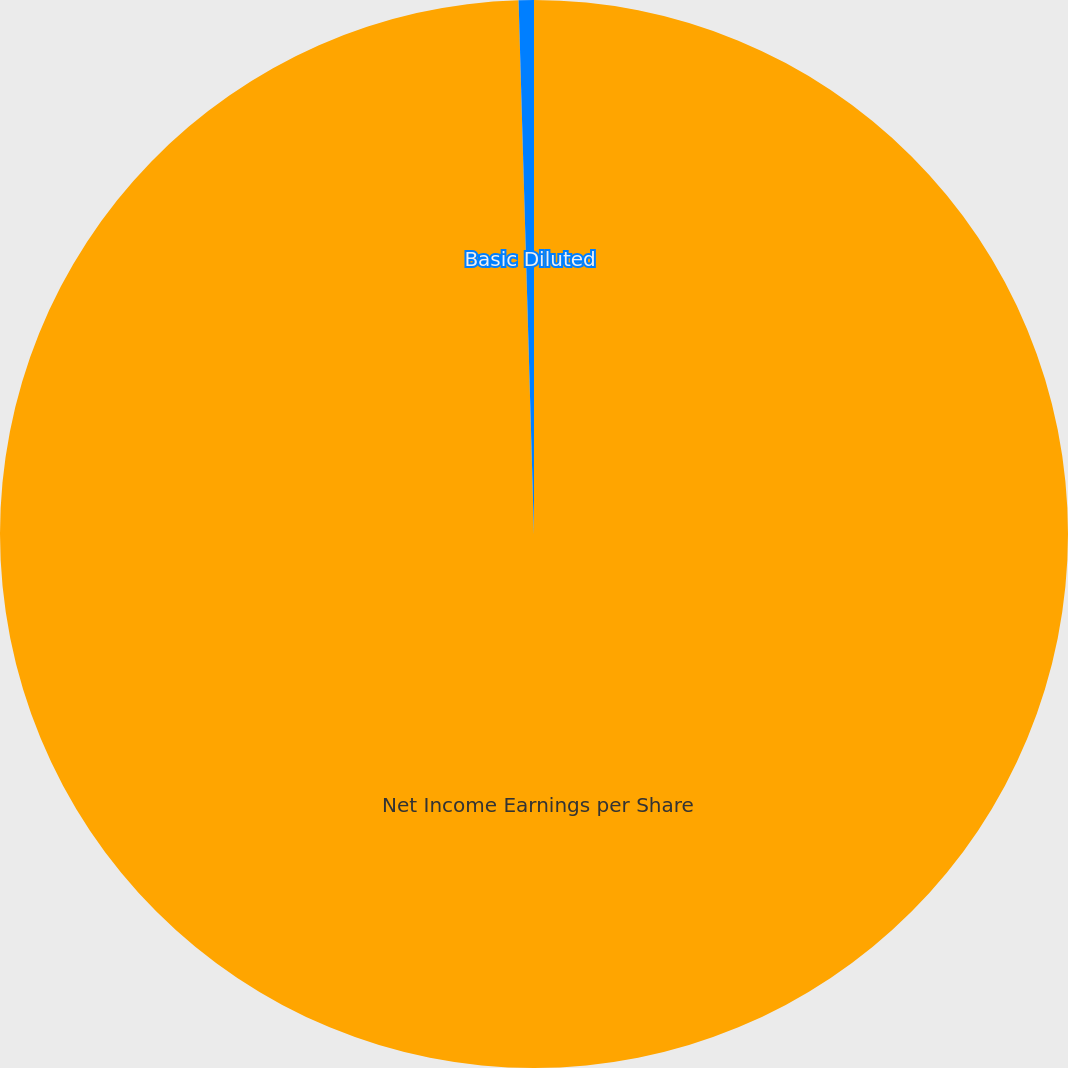Convert chart to OTSL. <chart><loc_0><loc_0><loc_500><loc_500><pie_chart><fcel>Net Income Earnings per Share<fcel>Basic Diluted<nl><fcel>99.54%<fcel>0.46%<nl></chart> 